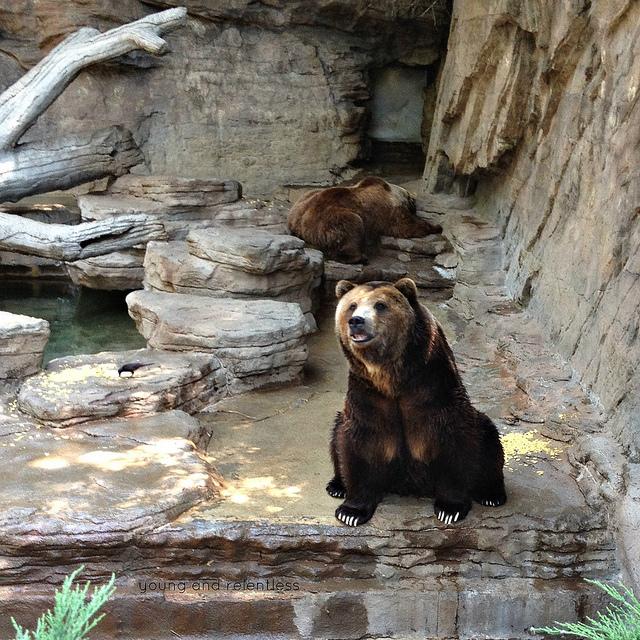Does the bear have large claws?
Keep it brief. Yes. Is the bear sitting on grass?
Concise answer only. No. Is this animal contained?
Keep it brief. Yes. 